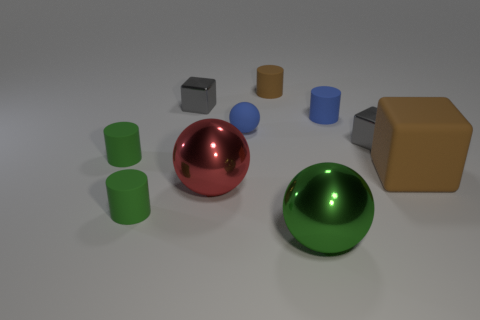There is a tiny matte cylinder behind the blue cylinder; is it the same color as the large rubber block?
Your answer should be very brief. Yes. What number of cylinders are large brown objects or small green things?
Provide a short and direct response. 2. What shape is the small metallic object to the left of the cylinder that is right of the big green metallic thing?
Offer a terse response. Cube. There is a shiny block that is on the left side of the large ball behind the small green cylinder in front of the large red sphere; how big is it?
Provide a succinct answer. Small. Is the blue rubber cylinder the same size as the brown cube?
Provide a succinct answer. No. How many things are tiny green rubber cylinders or brown rubber objects?
Your answer should be compact. 4. How big is the rubber cylinder in front of the brown rubber thing that is in front of the tiny brown object?
Provide a succinct answer. Small. The red object is what size?
Give a very brief answer. Large. The rubber thing that is both right of the large green ball and behind the large matte object has what shape?
Offer a terse response. Cylinder. The tiny thing that is the same shape as the large green thing is what color?
Give a very brief answer. Blue. 